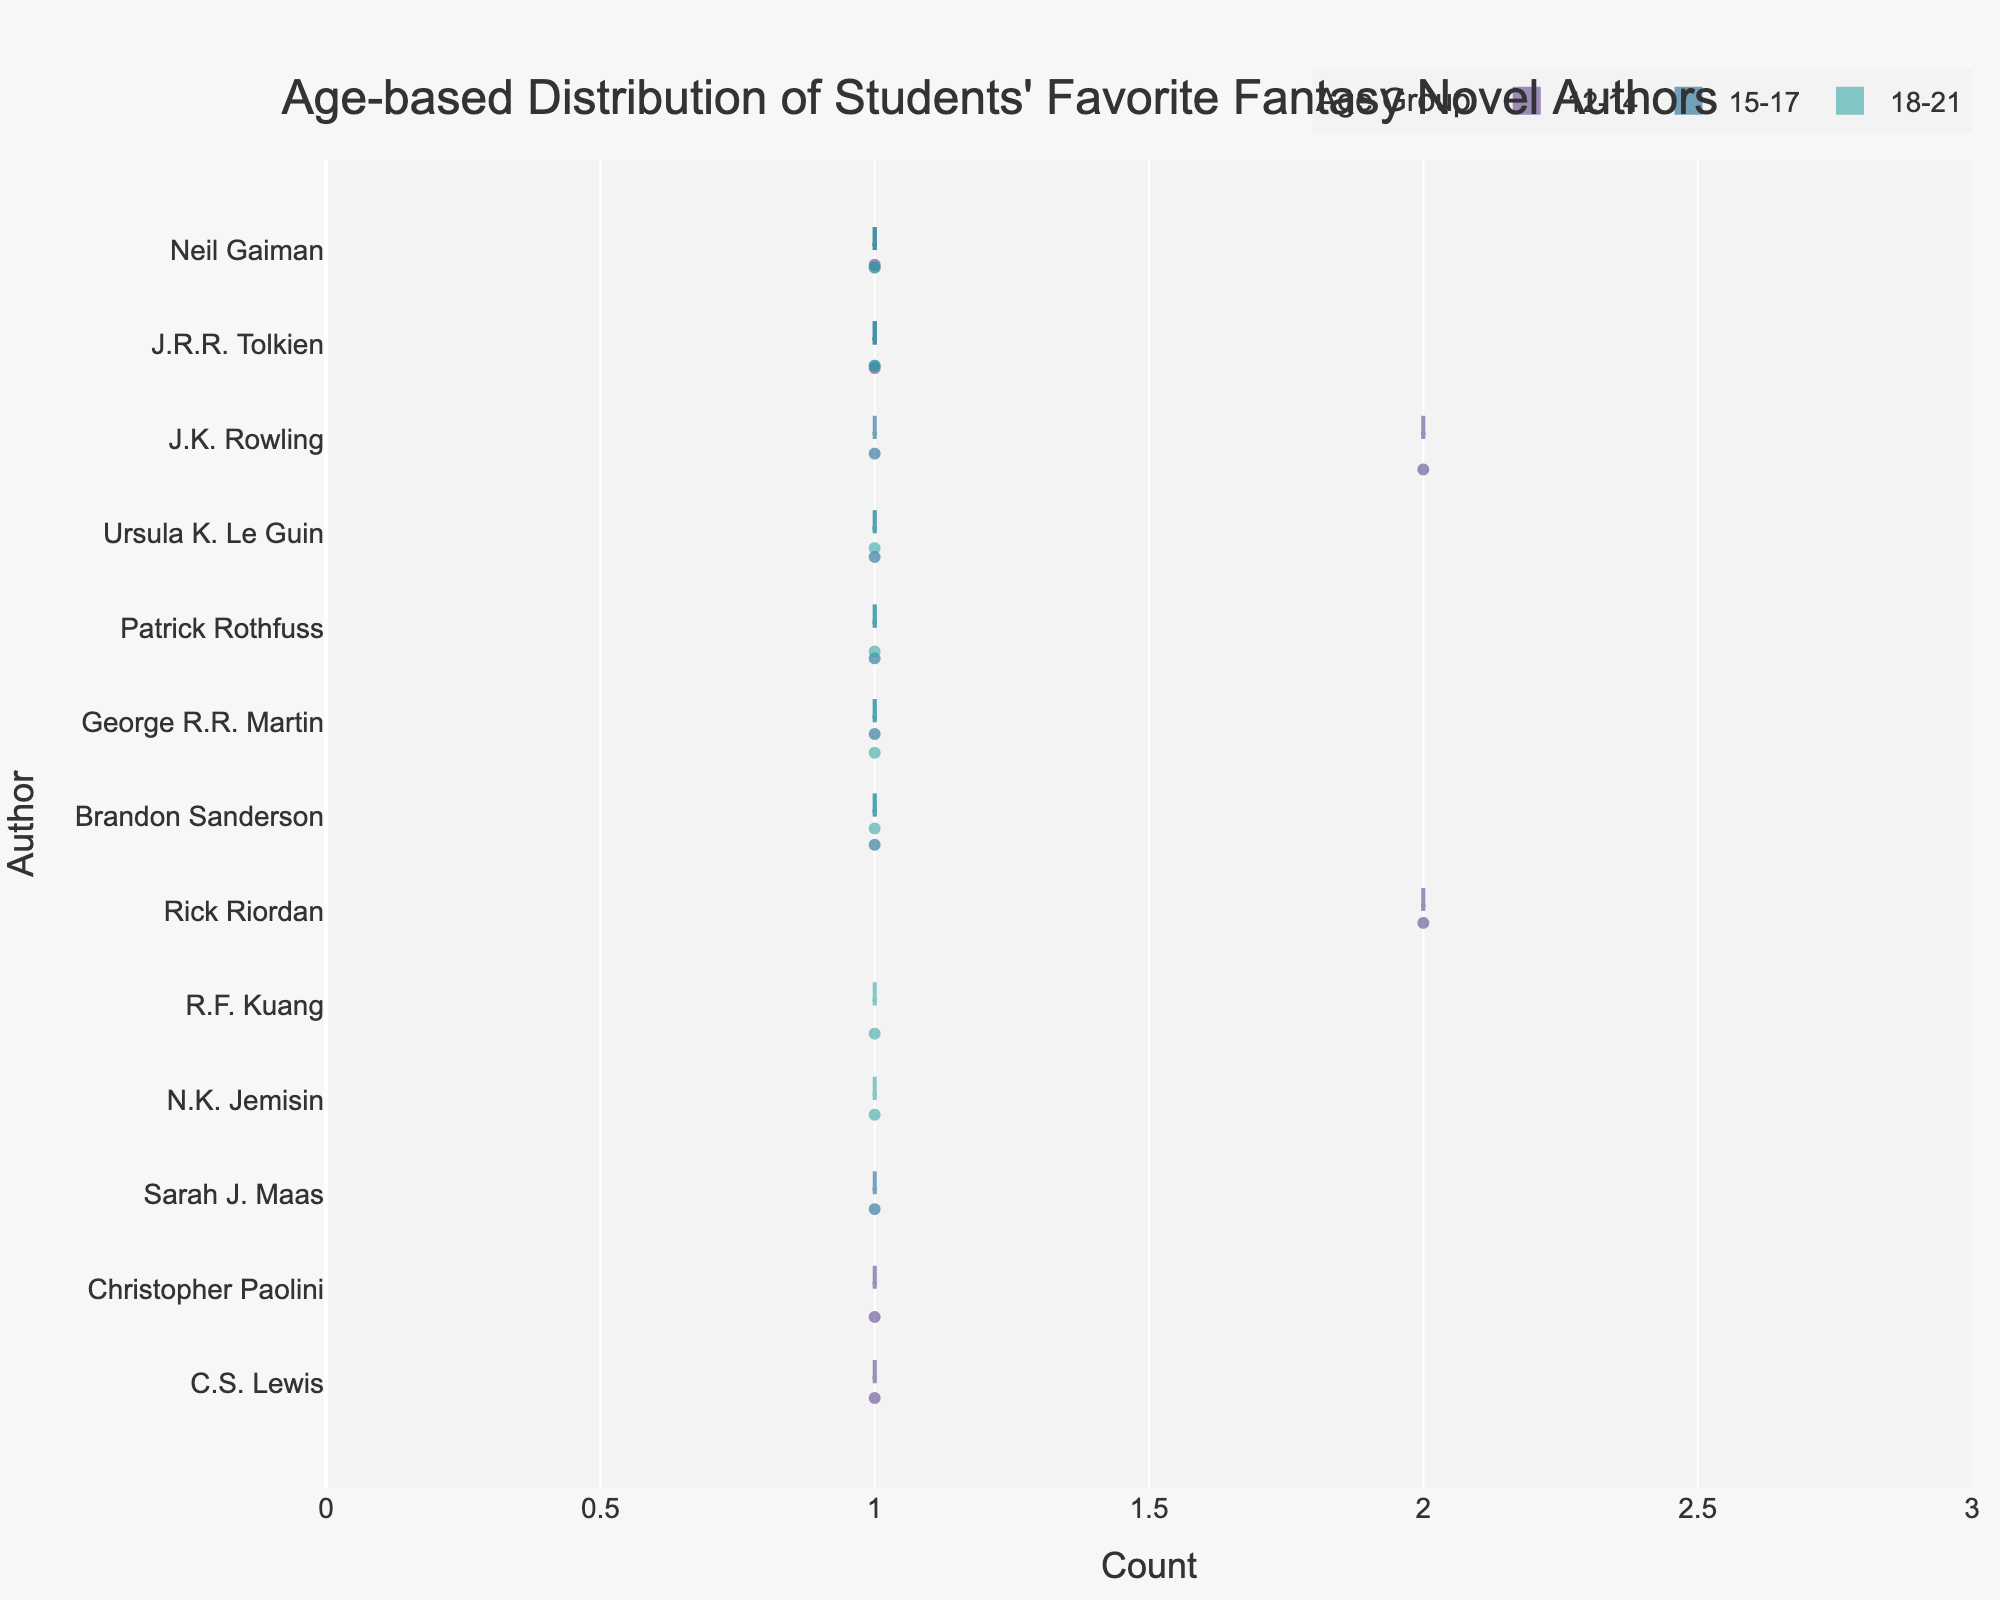What's the title of the chart? The title of the chart is displayed at the top and reads "Age-based Distribution of Students' Favorite Fantasy Novel Authors".
Answer: Age-based Distribution of Students' Favorite Fantasy Novel Authors Which authors appear in the age group 18-21? By carefully observing the y-axis labels within the segment labeled 18-21, the authors listed are George R.R. Martin, Brandon Sanderson, J.R.R. Tolkien, Neil Gaiman, Patrick Rothfuss, Ursula K. Le Guin, R.F. Kuang, and N.K. Jemisin.
Answer: George R.R. Martin, Brandon Sanderson, J.R.R. Tolkien, Neil Gaiman, Patrick Rothfuss, Ursula K. Le Guin, R.F. Kuang, N.K. Jemisin What is the largest count of any author in the age group 15-17? Looking at the horizontal spread for each author under the 15-17 age group, the longest length is for J.K. Rowling's distribution, reaching a count of 1.
Answer: 1 Which author is the most popular among the 12-14 age group based on the count? The author with the widest horizontal spread under the 12-14 group indicates the highest count is J.K. Rowling.
Answer: J.K. Rowling How many authors have a count greater than 1 in any age group? By identifying and counting the horizontal spread lengths greater than 1 across all age groups, only J.K. Rowling in the age group 12-14 meets this criterion.
Answer: 1 Which age group has the widest distribution of authors? By observing the y-axis categories and the spread of the authors, the 18-21 age group shows the widest distribution across multiple authors.
Answer: 18-21 Which author appears across all three age groups? By tracing the presence of authors through all age group segments on the y-axis, Neil Gaiman appears in all three groups: 12-14, 15-17, and 18-21.
Answer: Neil Gaiman What is the difference in the count for J.K. Rowling between the age groups 12-14 and 15-17? In the 12-14 age group, J.K. Rowling has a count of 2, while in the 15-17 age group, she has a count of 1. The difference is 2 - 1.
Answer: 1 Which age group prefers J.R.R. Tolkien the most? Comparing the count of J.R.R. Tolkien across age groups, the highest count observed is within the 18-21 group which also includes him.
Answer: 18-21 